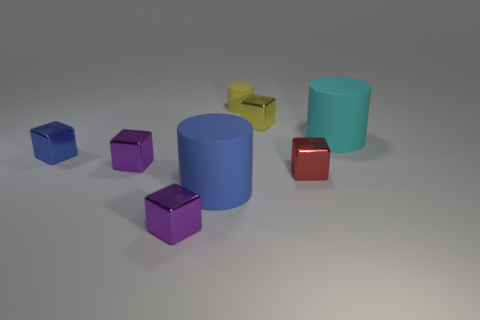Subtract all purple blocks. How many blocks are left? 3 Add 2 small gray matte spheres. How many objects exist? 10 Subtract 1 blocks. How many blocks are left? 4 Subtract all red blocks. How many blocks are left? 4 Add 7 tiny yellow blocks. How many tiny yellow blocks are left? 8 Add 6 tiny yellow shiny things. How many tiny yellow shiny things exist? 7 Subtract 0 purple cylinders. How many objects are left? 8 Subtract all blocks. How many objects are left? 3 Subtract all cyan blocks. Subtract all brown balls. How many blocks are left? 5 Subtract all yellow cylinders. How many purple cubes are left? 2 